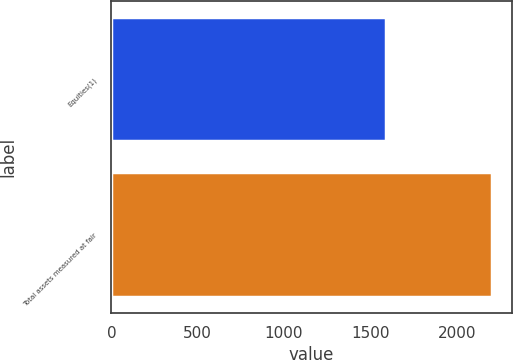Convert chart to OTSL. <chart><loc_0><loc_0><loc_500><loc_500><bar_chart><fcel>Equities(1)<fcel>Total assets measured at fair<nl><fcel>1589<fcel>2207<nl></chart> 